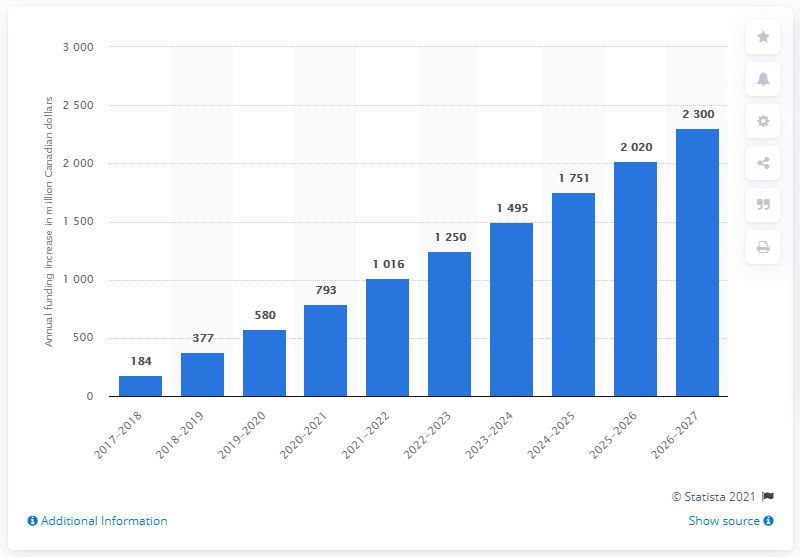List a handful of essential elements in this visual. I have a message that the defense budget of Canada is projected to be $2,300 billion in the year 2027. 